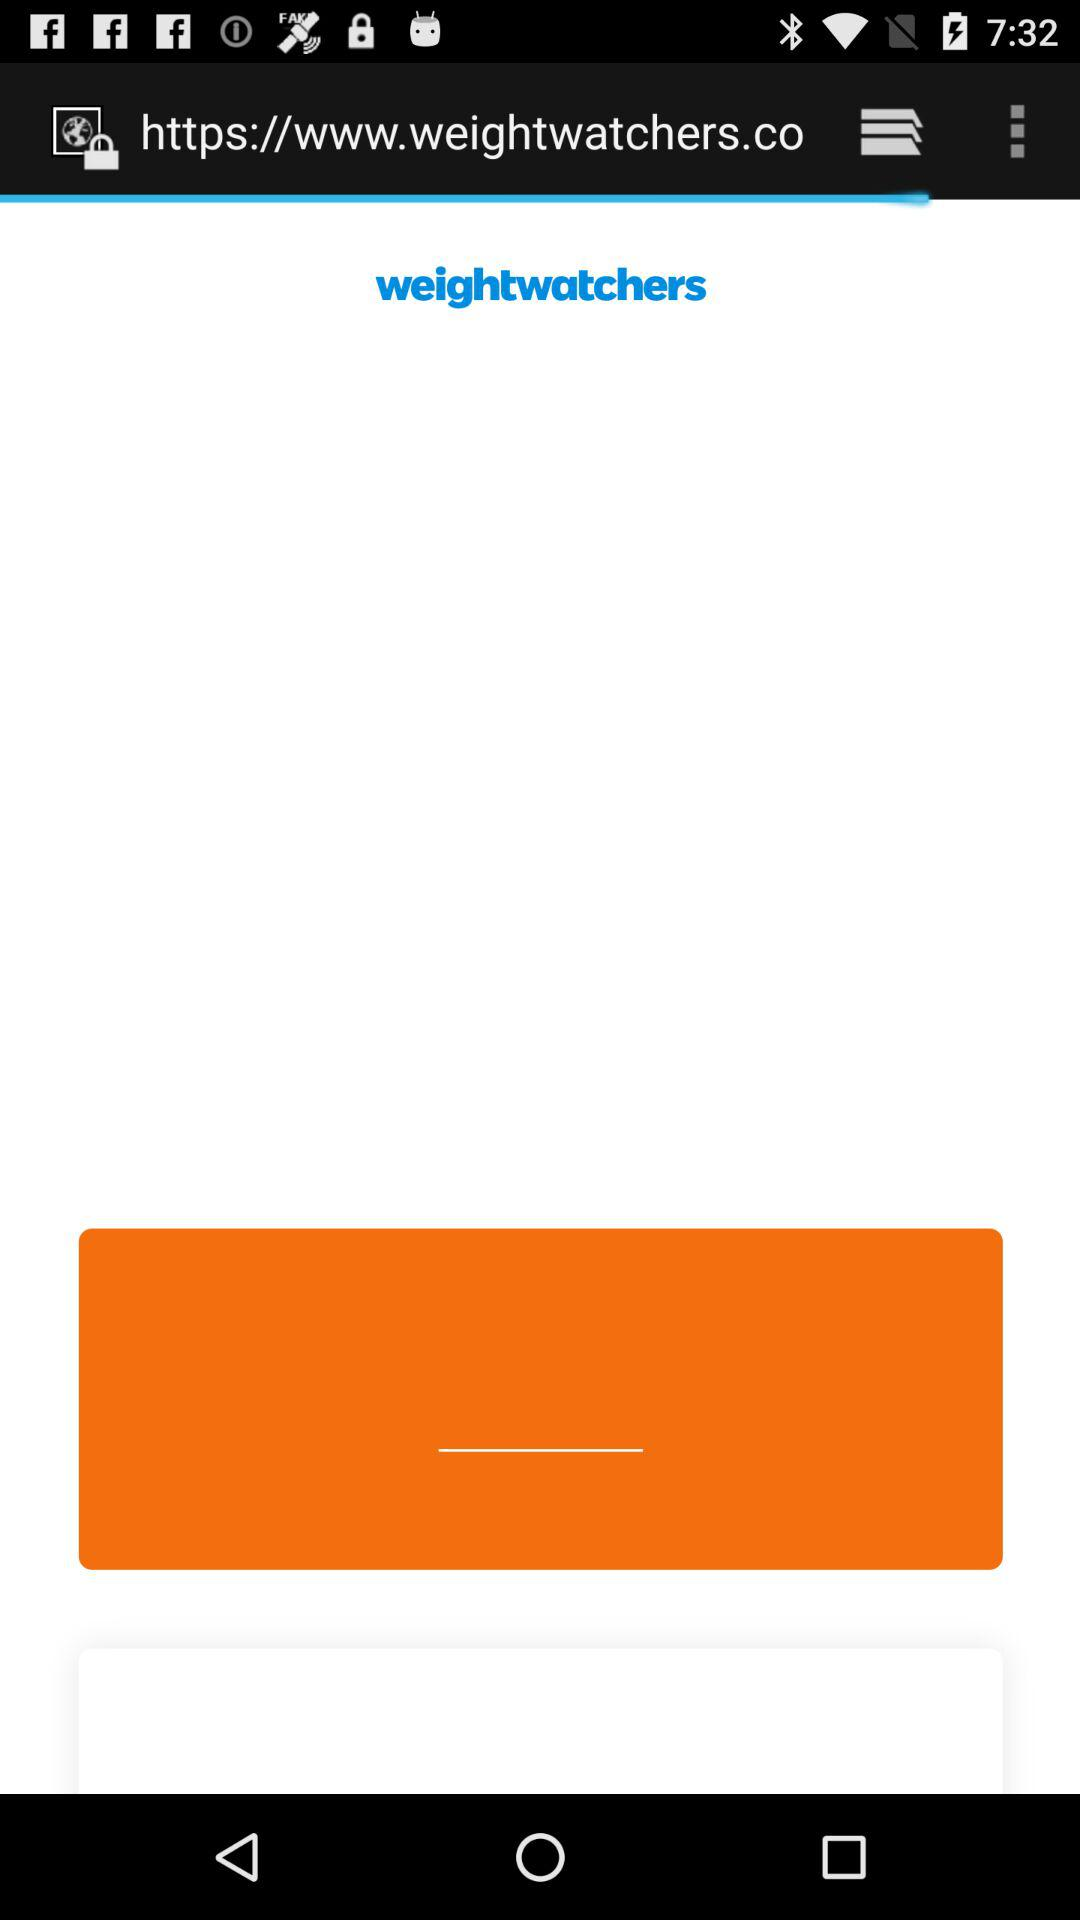What is the application name? The application name is "weightwatchers". 